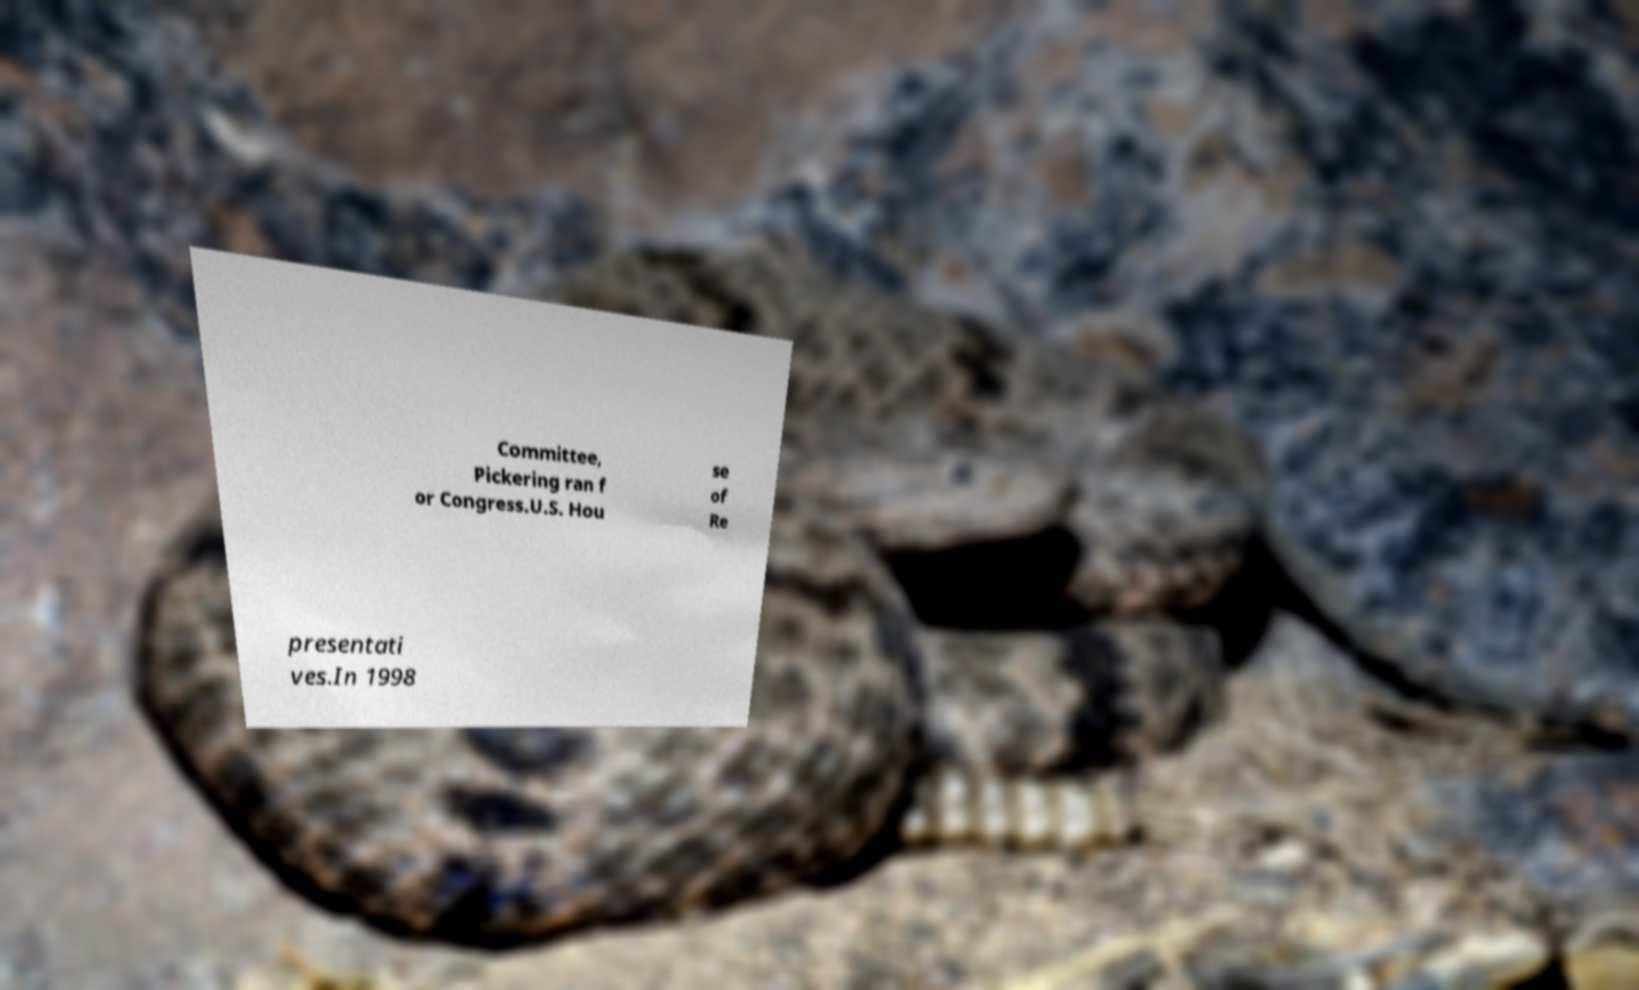I need the written content from this picture converted into text. Can you do that? Committee, Pickering ran f or Congress.U.S. Hou se of Re presentati ves.In 1998 